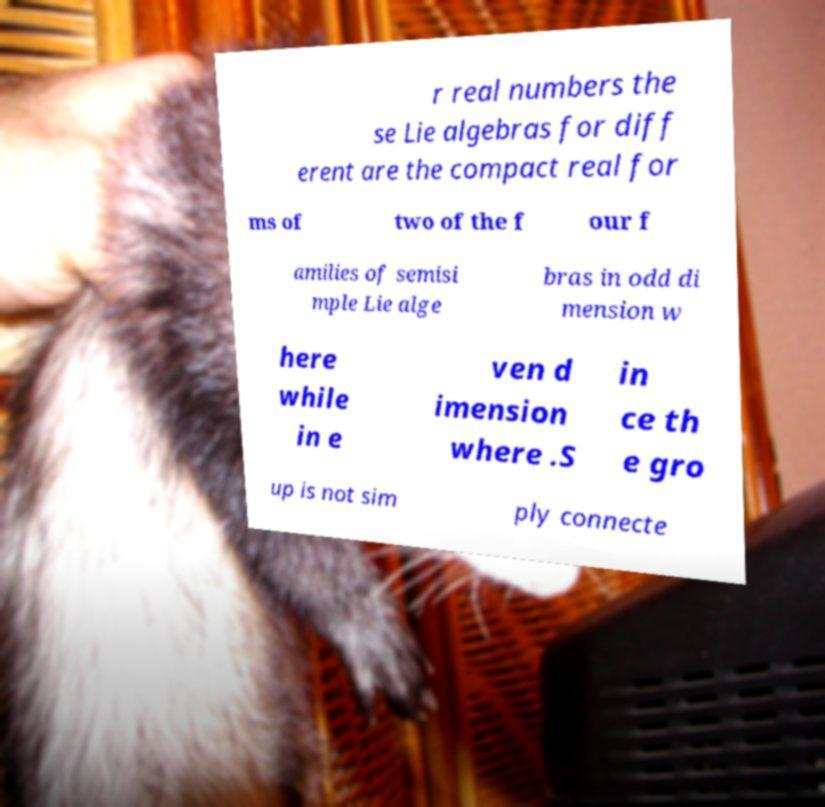I need the written content from this picture converted into text. Can you do that? r real numbers the se Lie algebras for diff erent are the compact real for ms of two of the f our f amilies of semisi mple Lie alge bras in odd di mension w here while in e ven d imension where .S in ce th e gro up is not sim ply connecte 